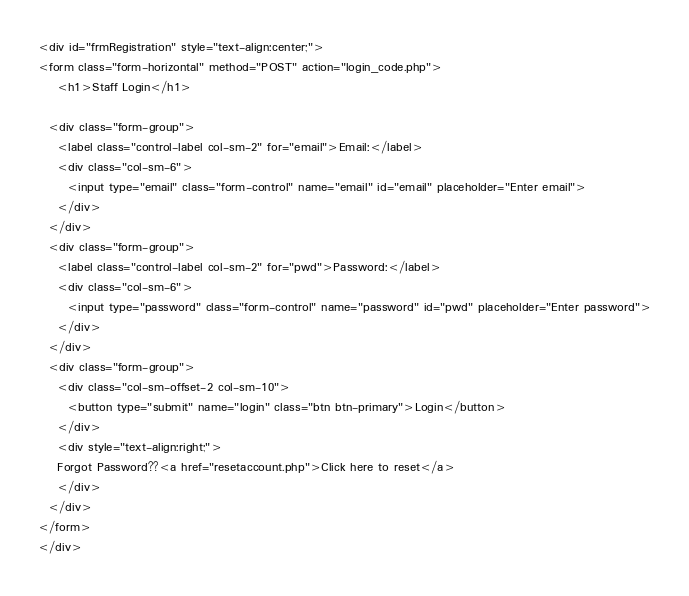<code> <loc_0><loc_0><loc_500><loc_500><_PHP_>
<div id="frmRegistration" style="text-align:center;">
<form class="form-horizontal" method="POST" action="login_code.php">
	<h1>Staff Login</h1>
	
  <div class="form-group">
    <label class="control-label col-sm-2" for="email">Email:</label>
    <div class="col-sm-6">
      <input type="email" class="form-control" name="email" id="email" placeholder="Enter email">
    </div>
  </div>
  <div class="form-group">
    <label class="control-label col-sm-2" for="pwd">Password:</label>
    <div class="col-sm-6"> 
      <input type="password" class="form-control" name="password" id="pwd" placeholder="Enter password">
    </div>
  </div>
  <div class="form-group"> 
    <div class="col-sm-offset-2 col-sm-10">
      <button type="submit" name="login" class="btn btn-primary">Login</button>
    </div>
	<div style="text-align:right;">
	Forgot Password??<a href="resetaccount.php">Click here to reset</a>
	</div>
  </div>
</form>
</div></code> 